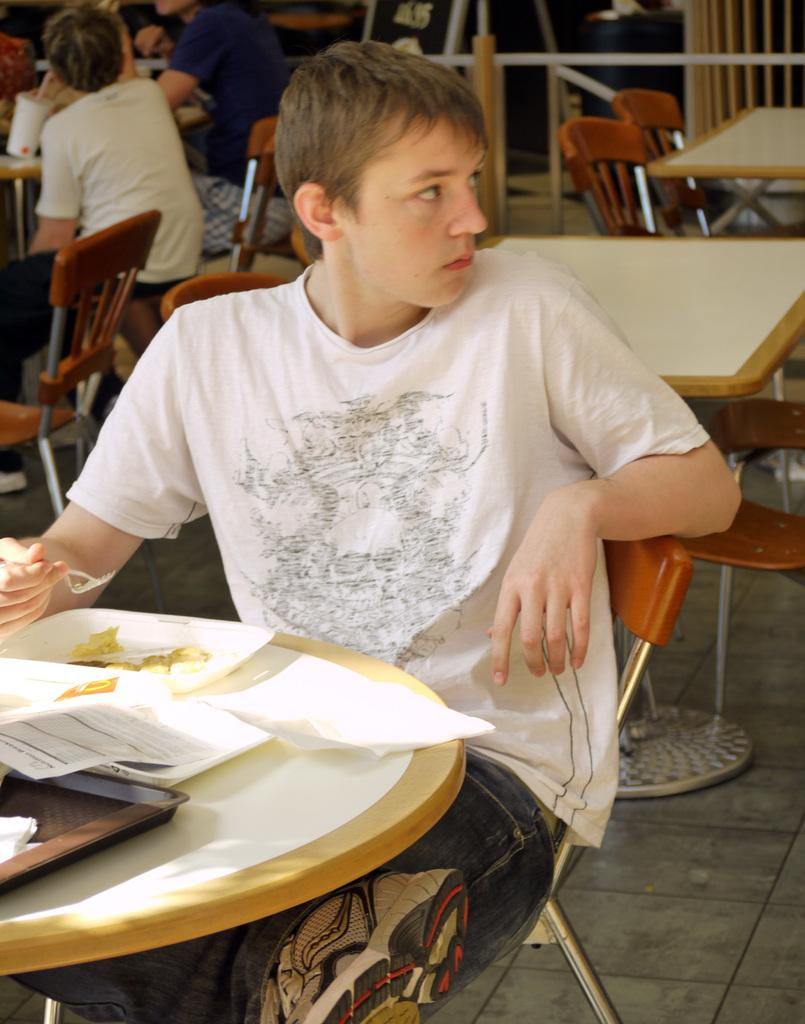What is the main subject of the image? The main subject of the image is a group of people. What are the people doing in the image? The people are seated on chairs in the image. What objects are in front of the people? There are papers in front of the people. What else can be seen in the image besides the people and papers? There is food on a table in the image. Can you tell me how many cans are visible in the image? There are no cans present in the image. What type of train can be seen passing by in the image? There is no train visible in the image. 